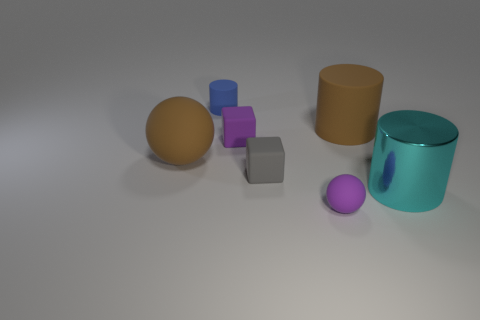Subtract all matte cylinders. How many cylinders are left? 1 Add 3 large purple things. How many objects exist? 10 Subtract all cubes. How many objects are left? 5 Add 4 tiny blue things. How many tiny blue things exist? 5 Subtract 0 purple cylinders. How many objects are left? 7 Subtract all large red rubber blocks. Subtract all small purple rubber cubes. How many objects are left? 6 Add 5 gray matte things. How many gray matte things are left? 6 